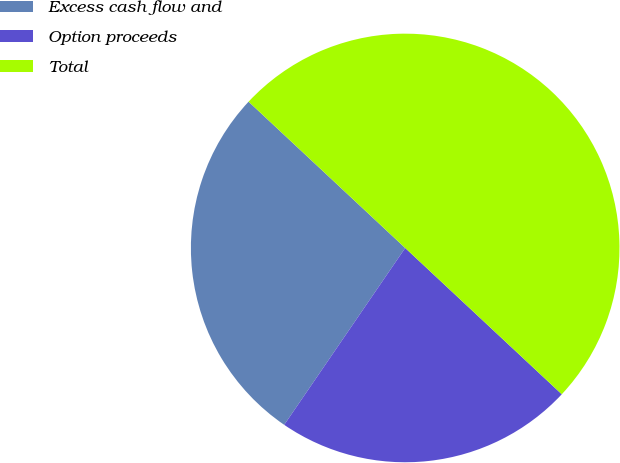Convert chart to OTSL. <chart><loc_0><loc_0><loc_500><loc_500><pie_chart><fcel>Excess cash flow and<fcel>Option proceeds<fcel>Total<nl><fcel>27.41%<fcel>22.59%<fcel>50.0%<nl></chart> 